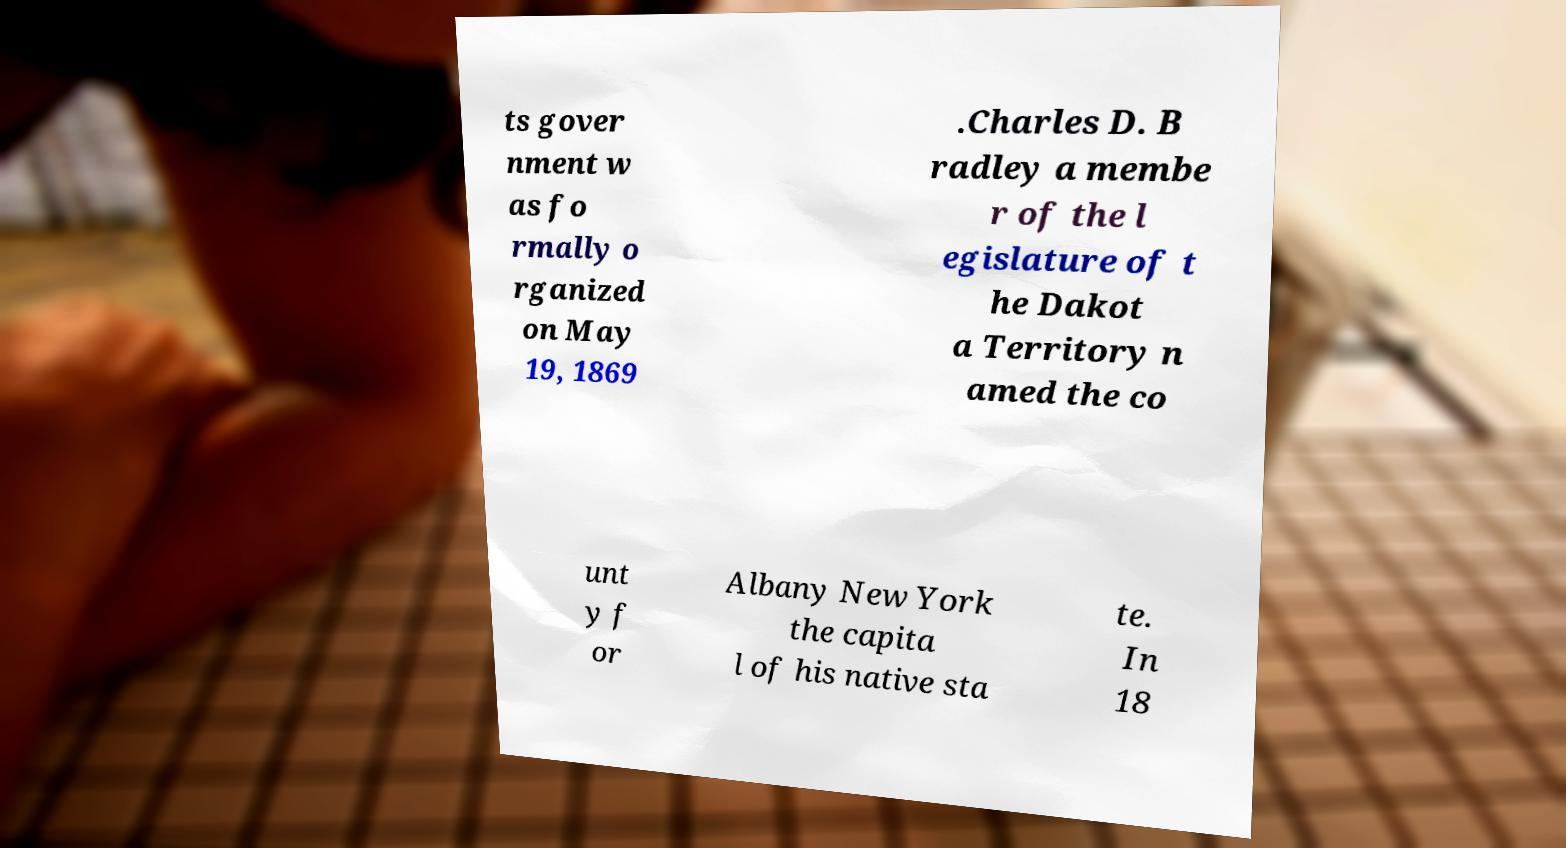Could you extract and type out the text from this image? ts gover nment w as fo rmally o rganized on May 19, 1869 .Charles D. B radley a membe r of the l egislature of t he Dakot a Territory n amed the co unt y f or Albany New York the capita l of his native sta te. In 18 